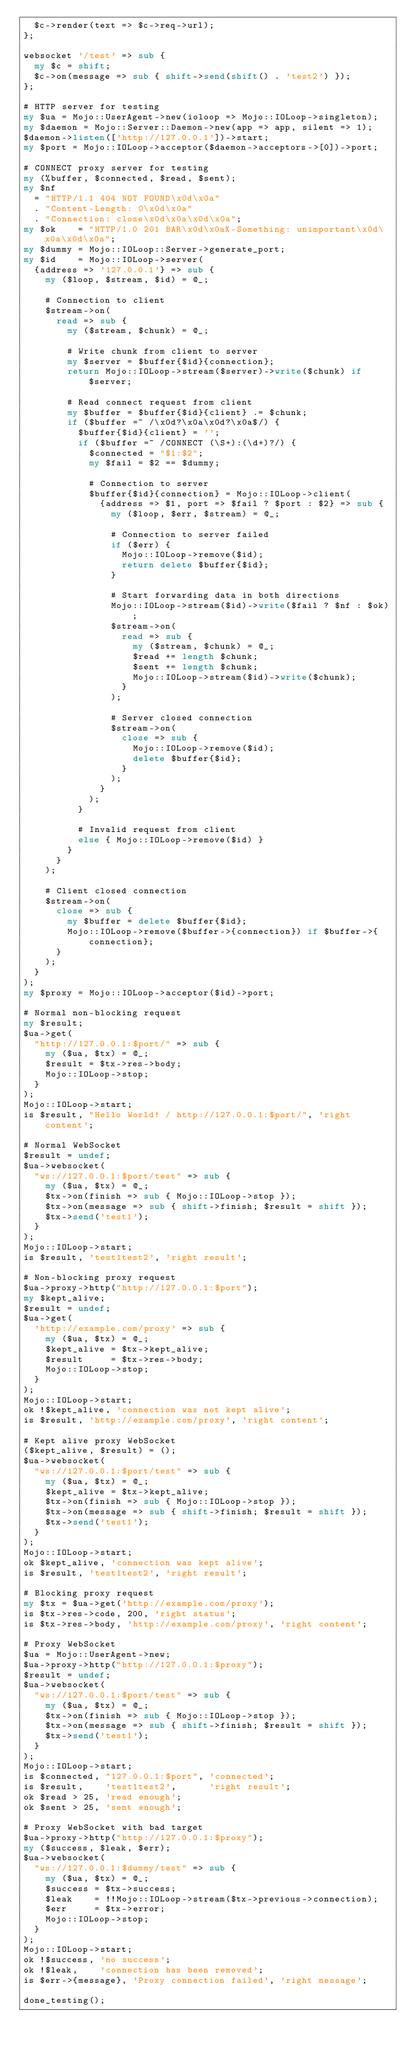Convert code to text. <code><loc_0><loc_0><loc_500><loc_500><_Perl_>  $c->render(text => $c->req->url);
};

websocket '/test' => sub {
  my $c = shift;
  $c->on(message => sub { shift->send(shift() . 'test2') });
};

# HTTP server for testing
my $ua = Mojo::UserAgent->new(ioloop => Mojo::IOLoop->singleton);
my $daemon = Mojo::Server::Daemon->new(app => app, silent => 1);
$daemon->listen(['http://127.0.0.1'])->start;
my $port = Mojo::IOLoop->acceptor($daemon->acceptors->[0])->port;

# CONNECT proxy server for testing
my (%buffer, $connected, $read, $sent);
my $nf
  = "HTTP/1.1 404 NOT FOUND\x0d\x0a"
  . "Content-Length: 0\x0d\x0a"
  . "Connection: close\x0d\x0a\x0d\x0a";
my $ok    = "HTTP/1.0 201 BAR\x0d\x0aX-Something: unimportant\x0d\x0a\x0d\x0a";
my $dummy = Mojo::IOLoop::Server->generate_port;
my $id    = Mojo::IOLoop->server(
  {address => '127.0.0.1'} => sub {
    my ($loop, $stream, $id) = @_;

    # Connection to client
    $stream->on(
      read => sub {
        my ($stream, $chunk) = @_;

        # Write chunk from client to server
        my $server = $buffer{$id}{connection};
        return Mojo::IOLoop->stream($server)->write($chunk) if $server;

        # Read connect request from client
        my $buffer = $buffer{$id}{client} .= $chunk;
        if ($buffer =~ /\x0d?\x0a\x0d?\x0a$/) {
          $buffer{$id}{client} = '';
          if ($buffer =~ /CONNECT (\S+):(\d+)?/) {
            $connected = "$1:$2";
            my $fail = $2 == $dummy;

            # Connection to server
            $buffer{$id}{connection} = Mojo::IOLoop->client(
              {address => $1, port => $fail ? $port : $2} => sub {
                my ($loop, $err, $stream) = @_;

                # Connection to server failed
                if ($err) {
                  Mojo::IOLoop->remove($id);
                  return delete $buffer{$id};
                }

                # Start forwarding data in both directions
                Mojo::IOLoop->stream($id)->write($fail ? $nf : $ok);
                $stream->on(
                  read => sub {
                    my ($stream, $chunk) = @_;
                    $read += length $chunk;
                    $sent += length $chunk;
                    Mojo::IOLoop->stream($id)->write($chunk);
                  }
                );

                # Server closed connection
                $stream->on(
                  close => sub {
                    Mojo::IOLoop->remove($id);
                    delete $buffer{$id};
                  }
                );
              }
            );
          }

          # Invalid request from client
          else { Mojo::IOLoop->remove($id) }
        }
      }
    );

    # Client closed connection
    $stream->on(
      close => sub {
        my $buffer = delete $buffer{$id};
        Mojo::IOLoop->remove($buffer->{connection}) if $buffer->{connection};
      }
    );
  }
);
my $proxy = Mojo::IOLoop->acceptor($id)->port;

# Normal non-blocking request
my $result;
$ua->get(
  "http://127.0.0.1:$port/" => sub {
    my ($ua, $tx) = @_;
    $result = $tx->res->body;
    Mojo::IOLoop->stop;
  }
);
Mojo::IOLoop->start;
is $result, "Hello World! / http://127.0.0.1:$port/", 'right content';

# Normal WebSocket
$result = undef;
$ua->websocket(
  "ws://127.0.0.1:$port/test" => sub {
    my ($ua, $tx) = @_;
    $tx->on(finish => sub { Mojo::IOLoop->stop });
    $tx->on(message => sub { shift->finish; $result = shift });
    $tx->send('test1');
  }
);
Mojo::IOLoop->start;
is $result, 'test1test2', 'right result';

# Non-blocking proxy request
$ua->proxy->http("http://127.0.0.1:$port");
my $kept_alive;
$result = undef;
$ua->get(
  'http://example.com/proxy' => sub {
    my ($ua, $tx) = @_;
    $kept_alive = $tx->kept_alive;
    $result     = $tx->res->body;
    Mojo::IOLoop->stop;
  }
);
Mojo::IOLoop->start;
ok !$kept_alive, 'connection was not kept alive';
is $result, 'http://example.com/proxy', 'right content';

# Kept alive proxy WebSocket
($kept_alive, $result) = ();
$ua->websocket(
  "ws://127.0.0.1:$port/test" => sub {
    my ($ua, $tx) = @_;
    $kept_alive = $tx->kept_alive;
    $tx->on(finish => sub { Mojo::IOLoop->stop });
    $tx->on(message => sub { shift->finish; $result = shift });
    $tx->send('test1');
  }
);
Mojo::IOLoop->start;
ok $kept_alive, 'connection was kept alive';
is $result, 'test1test2', 'right result';

# Blocking proxy request
my $tx = $ua->get('http://example.com/proxy');
is $tx->res->code, 200, 'right status';
is $tx->res->body, 'http://example.com/proxy', 'right content';

# Proxy WebSocket
$ua = Mojo::UserAgent->new;
$ua->proxy->http("http://127.0.0.1:$proxy");
$result = undef;
$ua->websocket(
  "ws://127.0.0.1:$port/test" => sub {
    my ($ua, $tx) = @_;
    $tx->on(finish => sub { Mojo::IOLoop->stop });
    $tx->on(message => sub { shift->finish; $result = shift });
    $tx->send('test1');
  }
);
Mojo::IOLoop->start;
is $connected, "127.0.0.1:$port", 'connected';
is $result,    'test1test2',      'right result';
ok $read > 25, 'read enough';
ok $sent > 25, 'sent enough';

# Proxy WebSocket with bad target
$ua->proxy->http("http://127.0.0.1:$proxy");
my ($success, $leak, $err);
$ua->websocket(
  "ws://127.0.0.1:$dummy/test" => sub {
    my ($ua, $tx) = @_;
    $success = $tx->success;
    $leak    = !!Mojo::IOLoop->stream($tx->previous->connection);
    $err     = $tx->error;
    Mojo::IOLoop->stop;
  }
);
Mojo::IOLoop->start;
ok !$success, 'no success';
ok !$leak,    'connection has been removed';
is $err->{message}, 'Proxy connection failed', 'right message';

done_testing();
</code> 